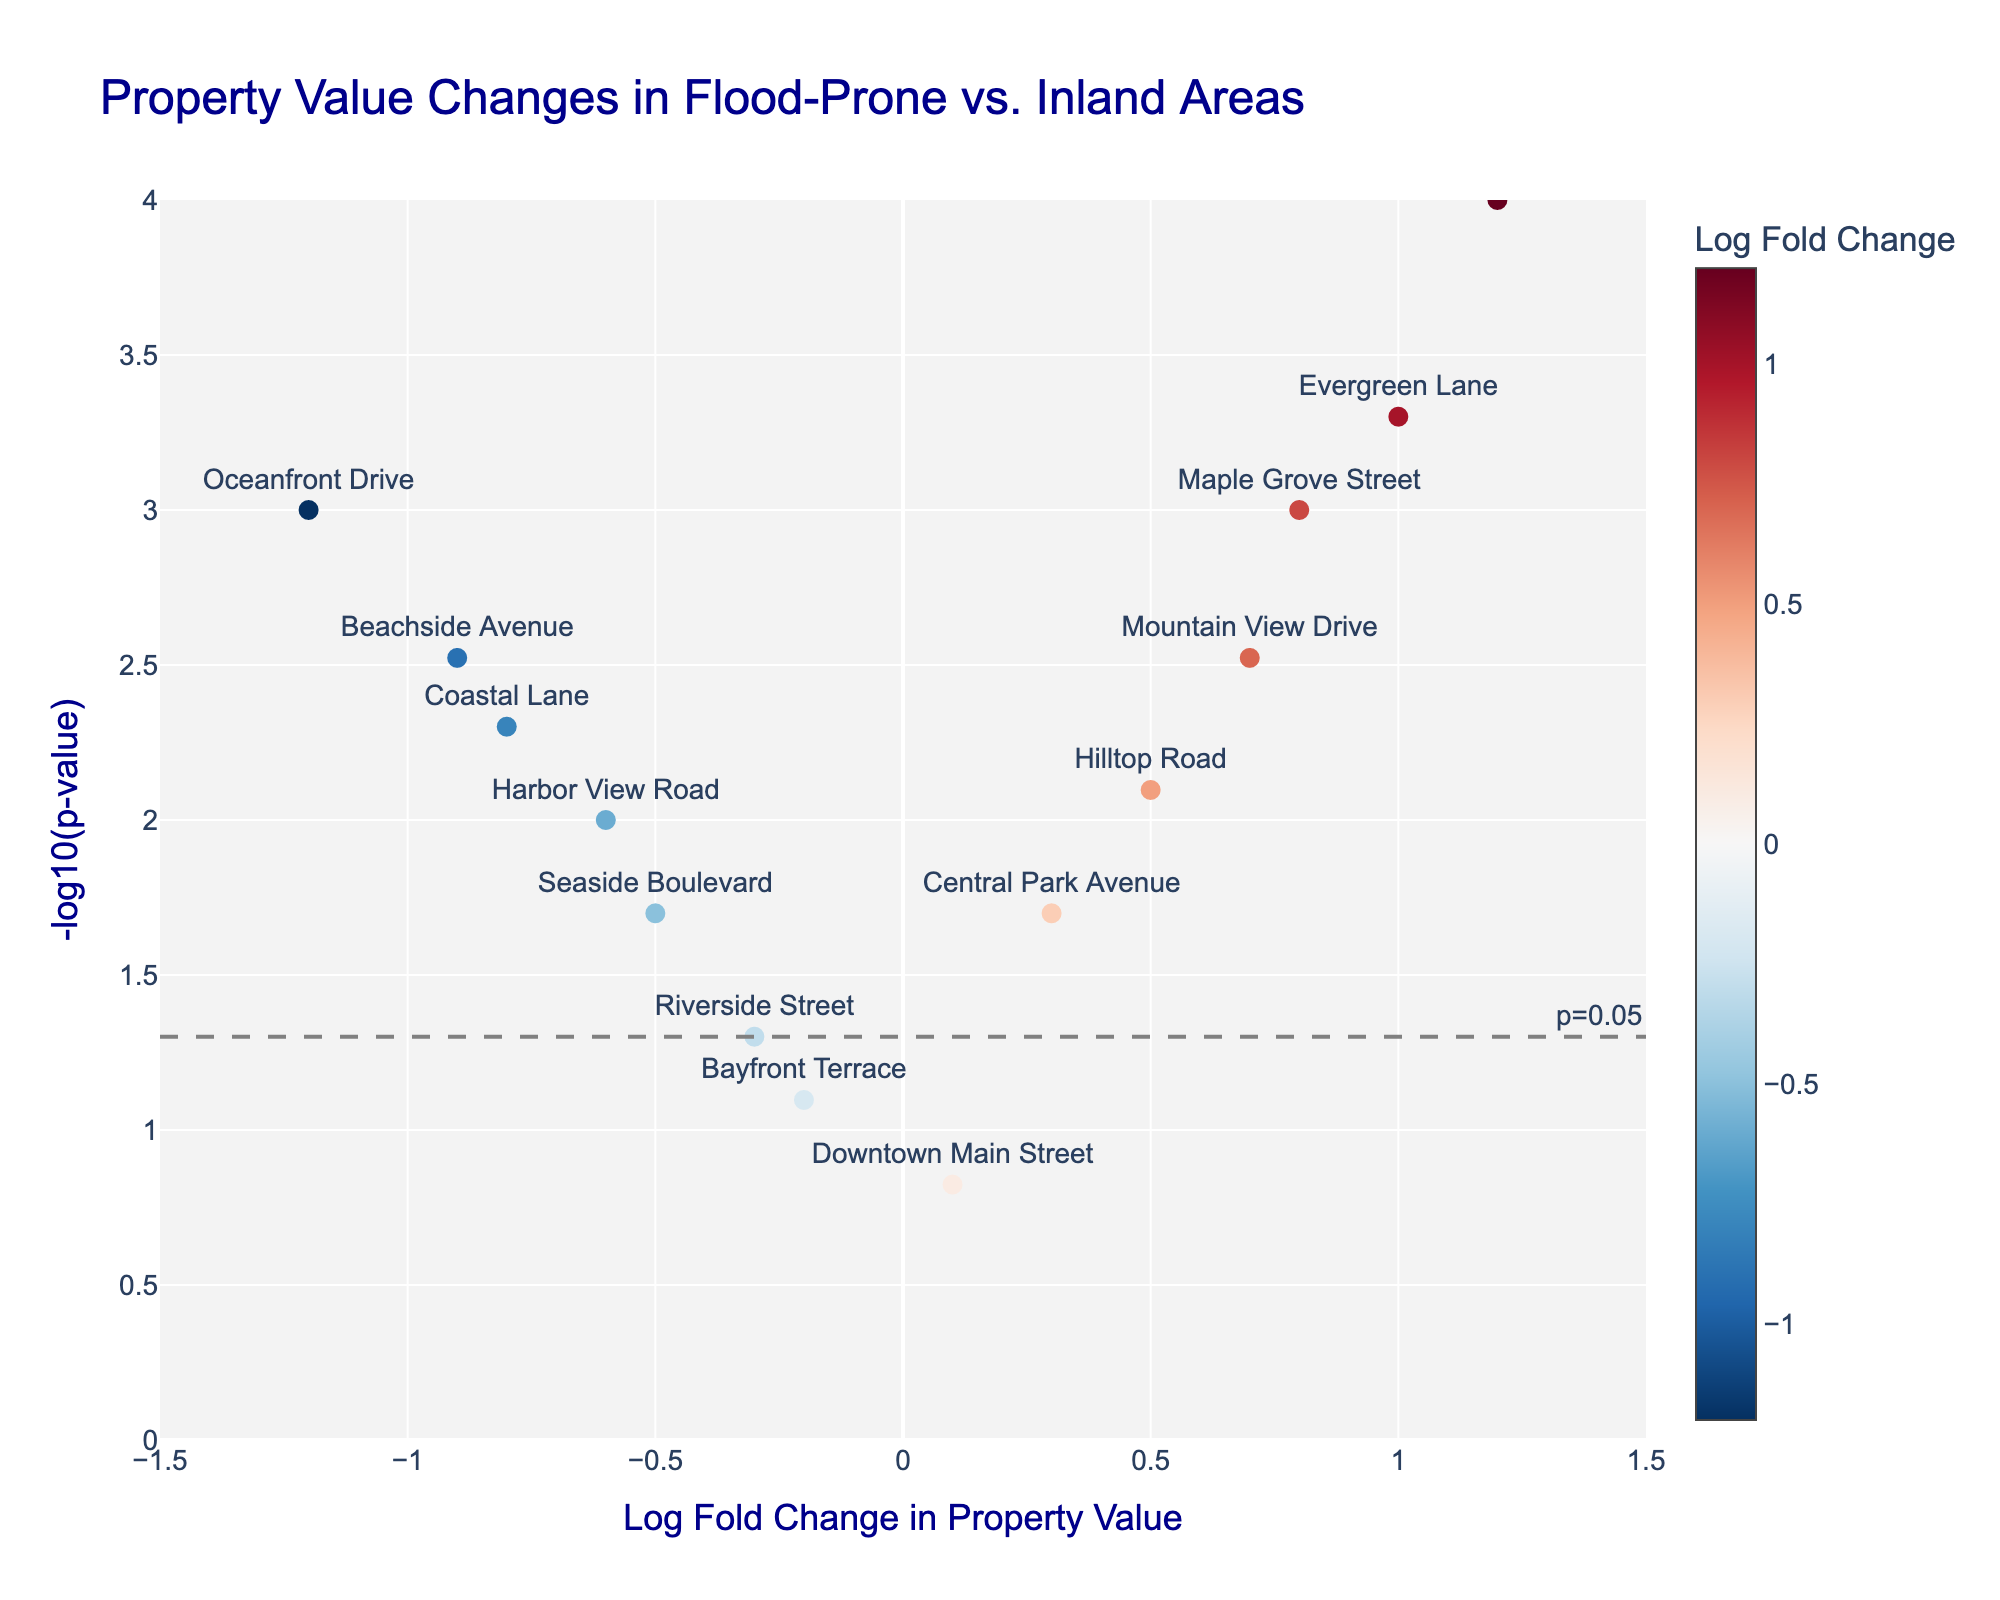What is the title of the plot? The title is usually the most prominent text at the top of the plot. It provides a concise summary of what the plot is about.
Answer: Property Value Changes in Flood-Prone vs. Inland Areas What are the axes labels and what do they represent? The x-axis is labeled "Log Fold Change in Property Value," which represents the logarithmic change in property value between flood-prone and inland areas. The y-axis is labeled "-log10(p-value)," which represents the negative logarithm of the p-value indicating statistical significance.
Answer: Log Fold Change in Property Value, -log10(p-value) Which property shows the highest increase in value? By looking at the plot, the highest Log Fold Change in Property Value on the positive side should be noted. The label "Highland Avenue" reaches the highest value.
Answer: Highland Avenue Which property has the lowest p-value? The property with the smallest p-value will have the highest point on the y-axis. "Highland Avenue" appears highest on the plot.
Answer: Highland Avenue How many properties have a statistically significant change in value (p-value < 0.05)? Properties with a p-value < 0.05 are above the dashed grey line labeled "p=0.05". There are 9 properties above this line.
Answer: 9 What can you say about the property value changes in flood-prone areas compared to safer inland locations? By checking the Log Fold Change values, we can see if properties in flood-prone areas (negative Log Fold Change) have decreased in value, while those in safer inland areas (positive Log Fold Change) have increased. Values show that flood-prone areas mostly have negative changes while safer inland locations have positive changes.
Answer: Flood-prone areas mostly exhibit decreased values, while safer inland areas show increased values Which property has the smallest change in value and is it statistically significant? The property closest to the center (0 on the x-axis) represents the smallest change. "Downtown Main Street" has a Log Fold Change of 0.1 and it's not above the significance threshold line (-log10(0.05)=1.3).
Answer: Downtown Main Street, not significant Among the properties with a positive change in value, which has the second smallest p-value? First, identify properties with positive Log Fold Change values, then find the one with the second highest -log10(p-value). "Evergreen Lane" is highest, followed by "Mountain View Drive".
Answer: Mountain View Drive What is the log fold change of "Oceanfront Drive" and is it statistically significant? Locate the label "Oceanfront Drive". Its Log Fold Change is -1.2 and its point is above the threshold, indicating statistical significance.
Answer: -1.2, significant What can be inferred about "Seaside Boulevard" in terms of its value change and statistical significance? Check the position of "Seaside Boulevard". Its Log Fold Change is -0.5 and it is below the significance threshold line, signifying a decline in value that is not statistically significant.
Answer: Decline, not significant 